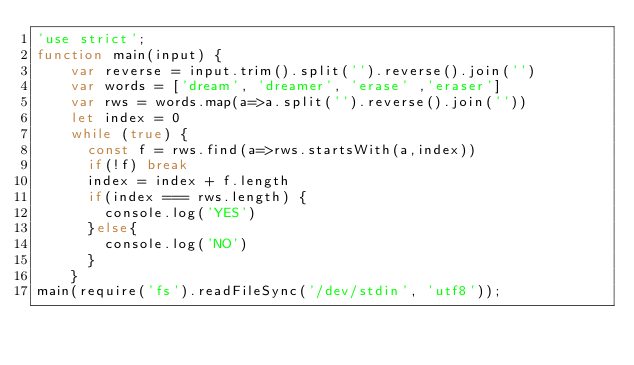Convert code to text. <code><loc_0><loc_0><loc_500><loc_500><_JavaScript_>'use strict';
function main(input) {
    var reverse = input.trim().split('').reverse().join('')
    var words = ['dream', 'dreamer', 'erase' ,'eraser']
    var rws = words.map(a=>a.split('').reverse().join(''))
    let index = 0
	while (true) {
      const f = rws.find(a=>rws.startsWith(a,index))
      if(!f) break
      index = index + f.length
      if(index === rws.length) {
        console.log('YES')
      }else{
        console.log('NO')
      }
    }
main(require('fs').readFileSync('/dev/stdin', 'utf8'));</code> 